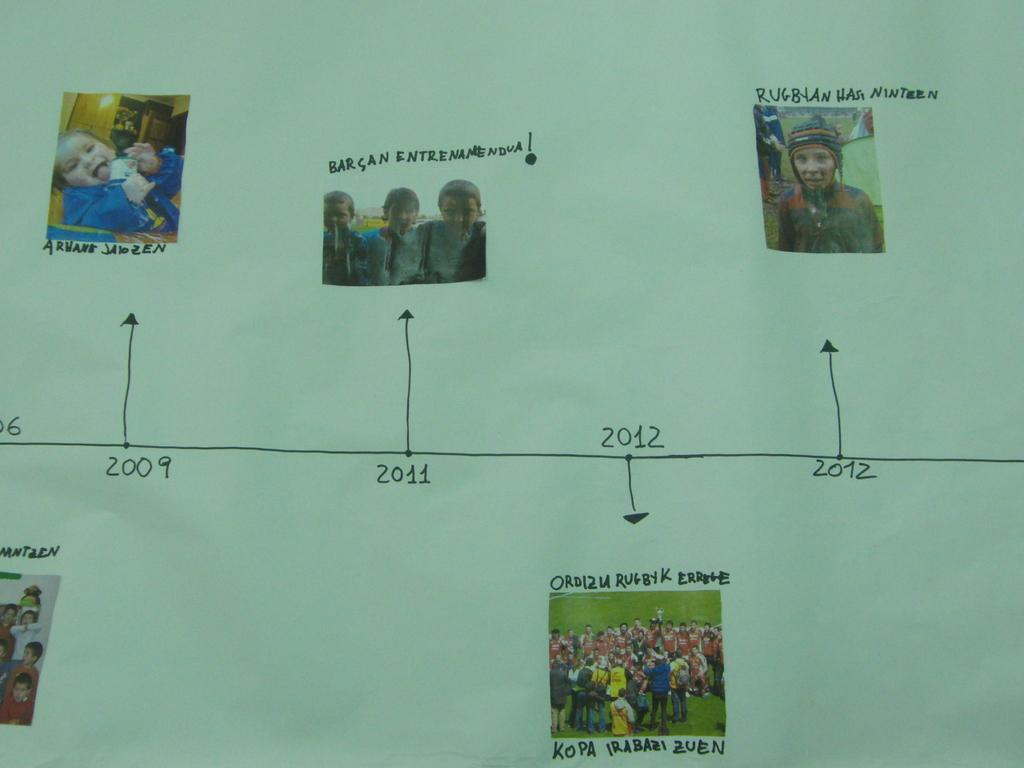What is the main subject of the image? The main subject of the image is a chart. What else can be seen in the image besides the chart? There are pictures pasted on a poster and writing on the poster in the image. What type of flowers are depicted in the art on the poster? There is no art or flowers depicted on the poster in the image; it features pictures and writing. 